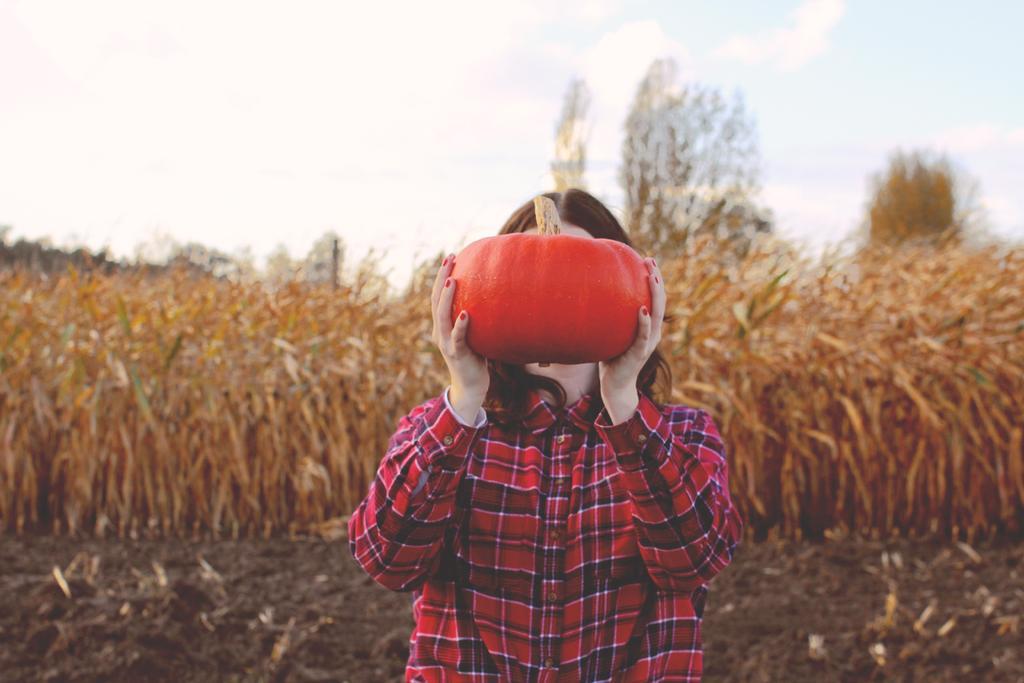Could you give a brief overview of what you see in this image? In this image I can see the person holding some object and the person is wearing red color shirt. In the background I can see the grass in brown color and the sky is in white color. 